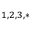Convert formula to latex. <formula><loc_0><loc_0><loc_500><loc_500>^ { 1 , 2 , 3 , * }</formula> 